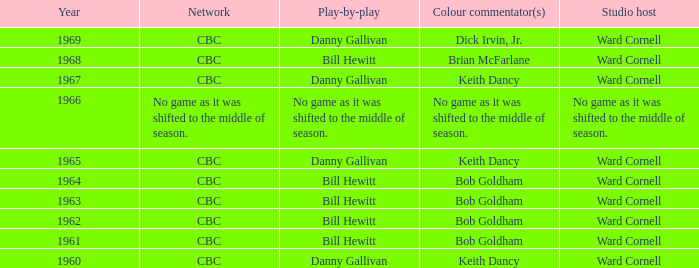Who executed the play-by-play in collaboration with studio presenter ward cornell and color commentator bob goldham? Bill Hewitt, Bill Hewitt, Bill Hewitt, Bill Hewitt. 